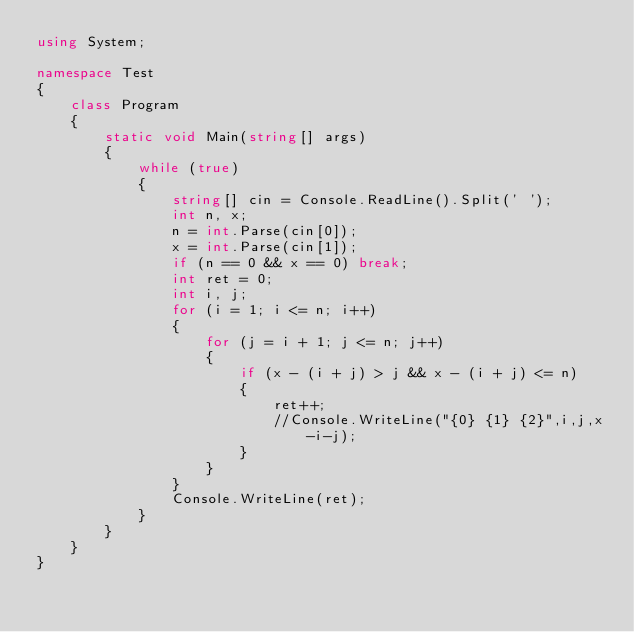Convert code to text. <code><loc_0><loc_0><loc_500><loc_500><_C#_>using System;

namespace Test
{
    class Program
    {
        static void Main(string[] args)
        {
            while (true)
            {
                string[] cin = Console.ReadLine().Split(' ');
                int n, x;
                n = int.Parse(cin[0]);
                x = int.Parse(cin[1]);
                if (n == 0 && x == 0) break;
                int ret = 0;
                int i, j;
                for (i = 1; i <= n; i++)
                {
                    for (j = i + 1; j <= n; j++)
                    {
                        if (x - (i + j) > j && x - (i + j) <= n)
                        {
                            ret++;
                            //Console.WriteLine("{0} {1} {2}",i,j,x-i-j);
                        }
                    }
                }
                Console.WriteLine(ret);
            }
        }
    }
}

</code> 